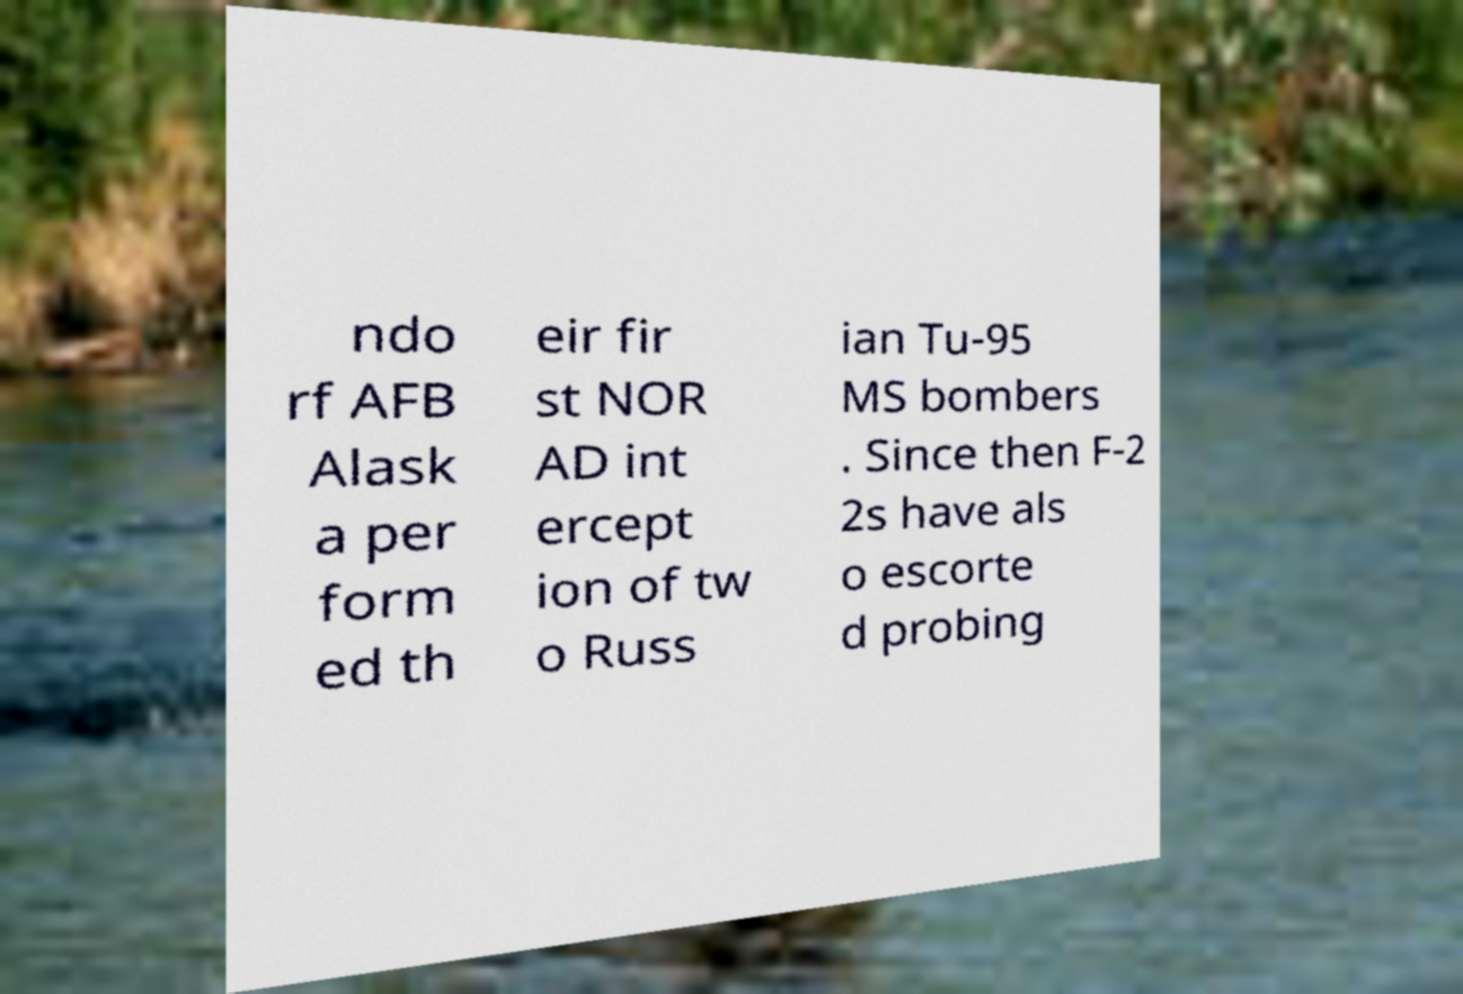Can you accurately transcribe the text from the provided image for me? ndo rf AFB Alask a per form ed th eir fir st NOR AD int ercept ion of tw o Russ ian Tu-95 MS bombers . Since then F-2 2s have als o escorte d probing 